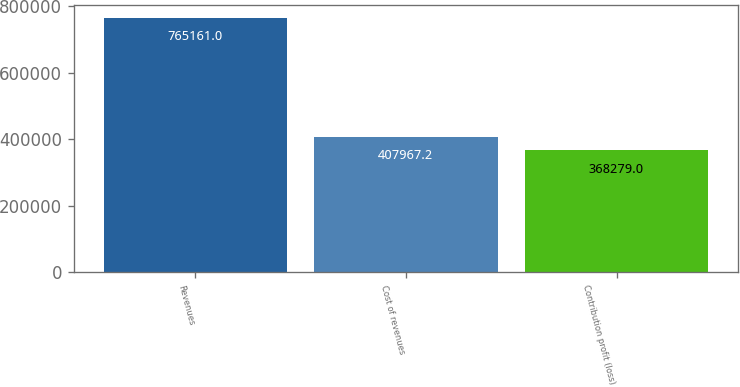Convert chart to OTSL. <chart><loc_0><loc_0><loc_500><loc_500><bar_chart><fcel>Revenues<fcel>Cost of revenues<fcel>Contribution profit (loss)<nl><fcel>765161<fcel>407967<fcel>368279<nl></chart> 